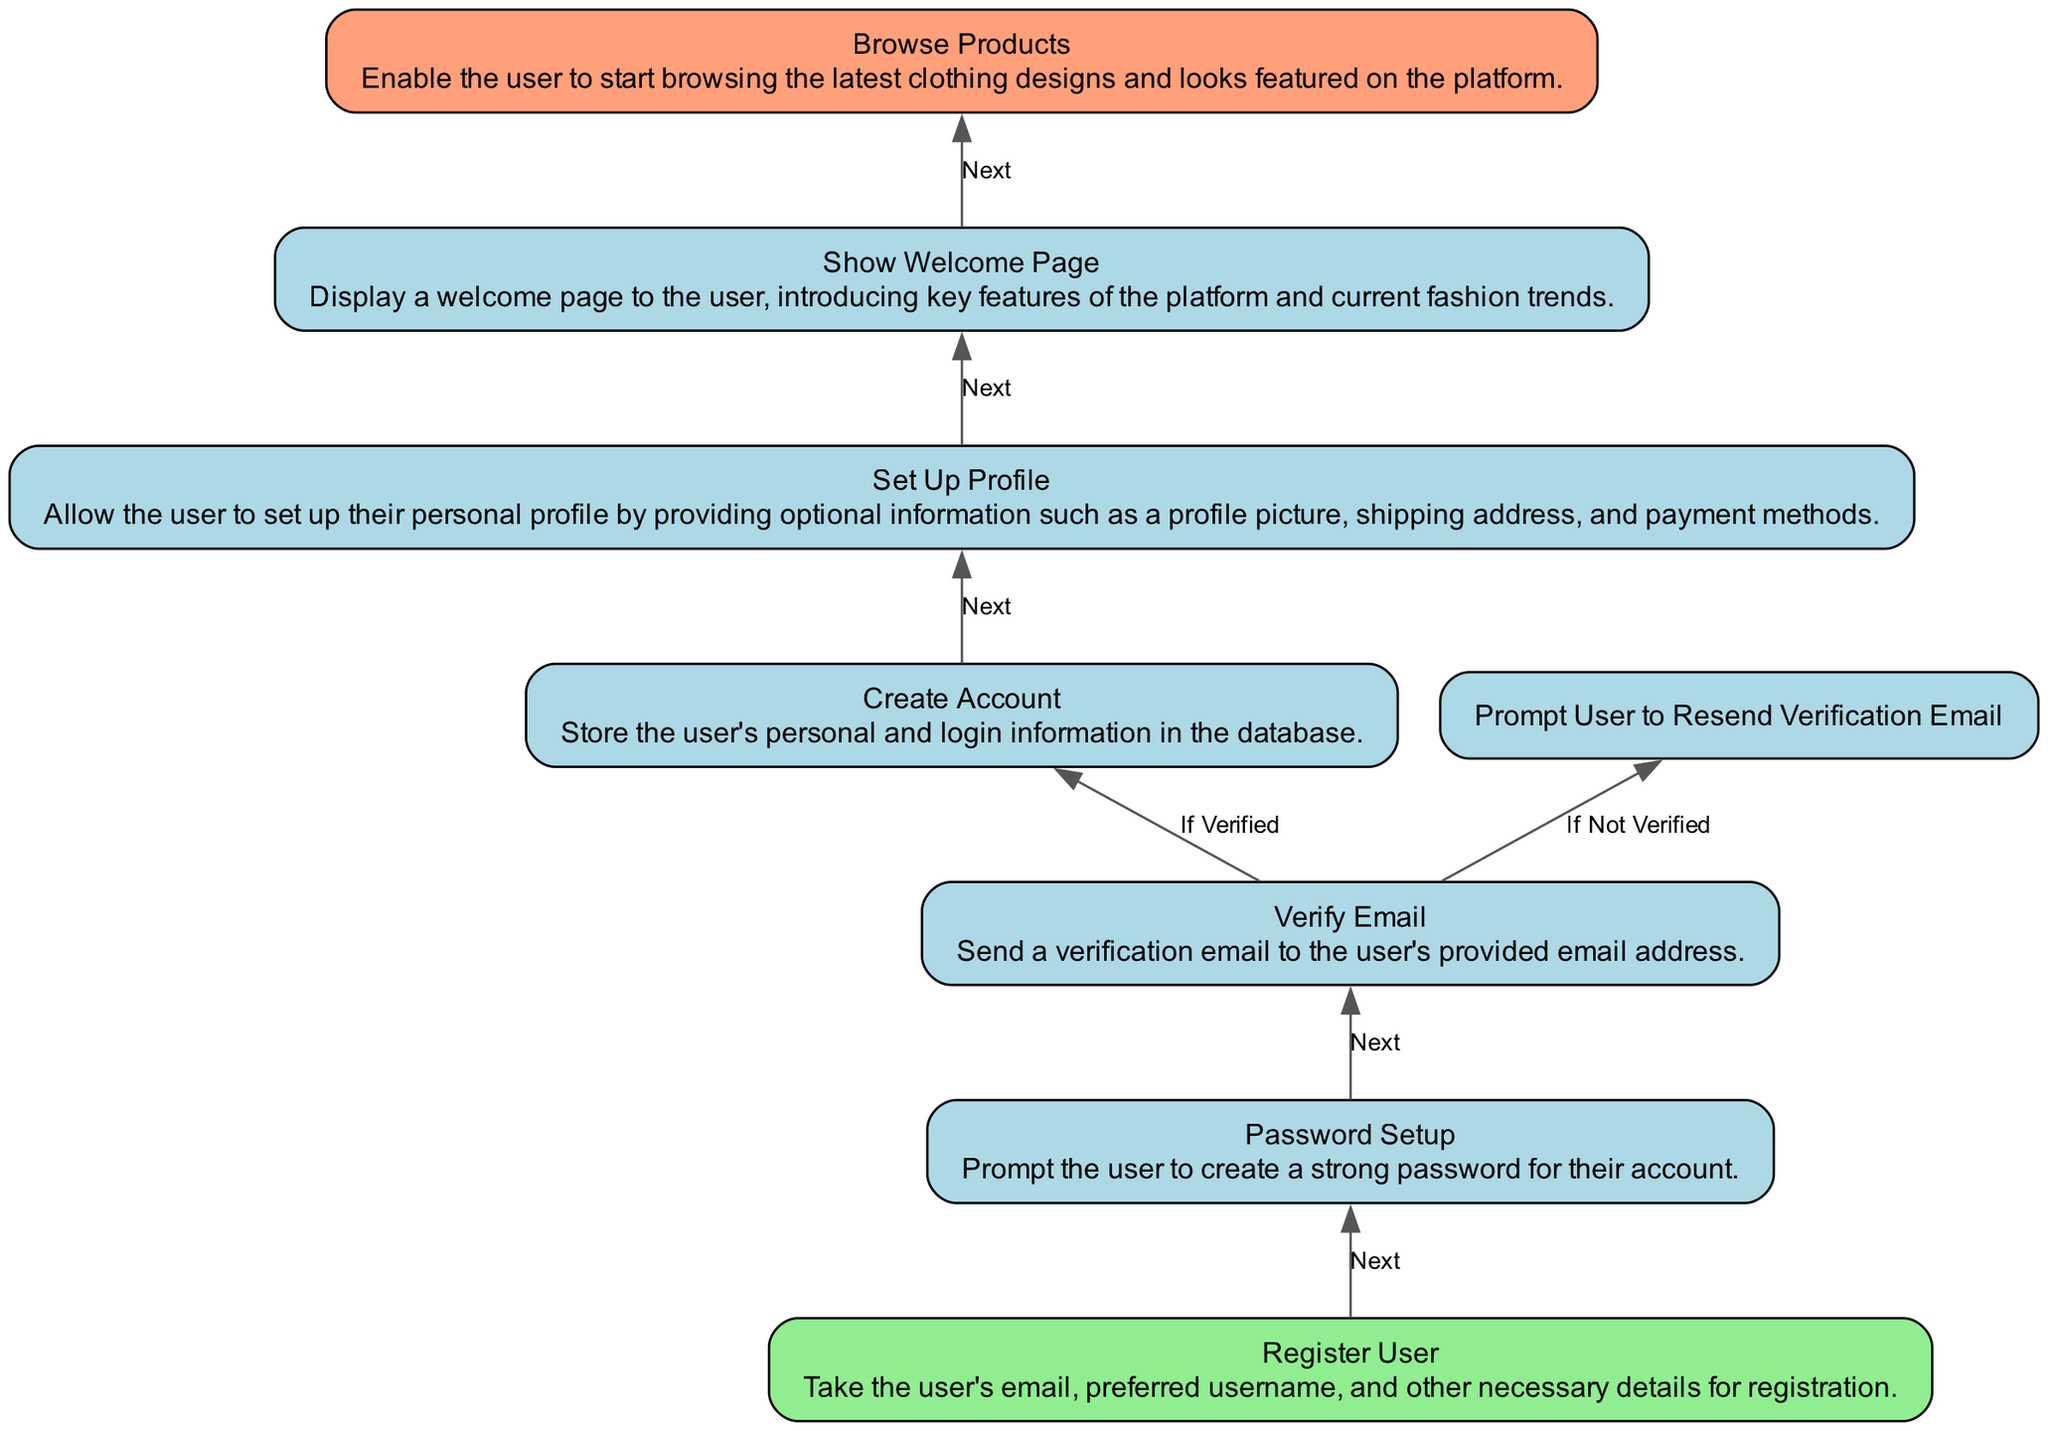What is the starting point of the flowchart? The flowchart starts with the "Register User" node, which is identified as the first step in the user authentication and account creation process.
Answer: Register User How many nodes are present in the diagram? By counting all distinctive entities in the diagram, we find there are a total of 7 nodes representing various steps in the process.
Answer: 7 What happens after "Create Account"? After the user’s account is created, the next step is "Set Up Profile", which involves providing more personal information.
Answer: Set Up Profile What is displayed after "Show Welcome Page"? Following "Show Welcome Page", the next step allows the user to "Browse Products", enabling them to explore available merchandise on the platform.
Answer: Browse Products What steps occur if the user does not verify their email? If the user does not verify their email, they are prompted to resend the verification email instead of progressing in the flow.
Answer: Prompt User to Resend Verification Email What node immediately follows "Password Setup"? Immediately after "Password Setup", the process goes to "Verify Email", which requires the user to verify the email they registered with.
Answer: Verify Email How does a user reach the "Browse Products" node? The user reaches "Browse Products" by first completing all previous steps: registering, setting up a password, verifying their email, creating the account, and setting up the profile, then viewing the welcome page.
Answer: Through multiple steps What indicates the end of the process in this flowchart? The process is terminated at the "Browse Products" node, which signifies that the user has completed all prior steps and can now start exploring the products.
Answer: Browse Products 